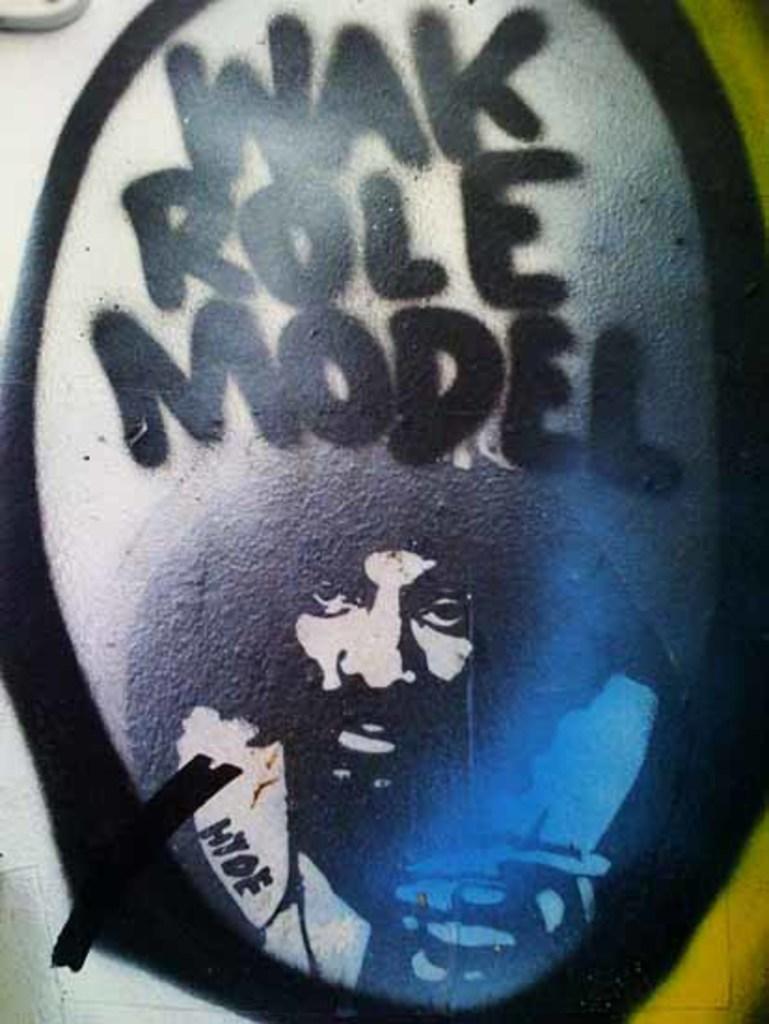Describe this image in one or two sentences. In this image there is a tattoo as we can see the person's face in the bottom of this image and there is some text on the top of this image. 